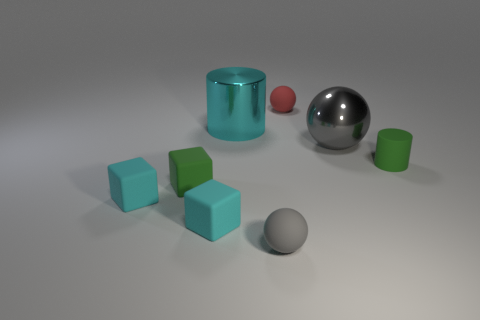Subtract all green spheres. How many cyan blocks are left? 2 Subtract all small cyan rubber blocks. How many blocks are left? 1 Add 1 small cyan cylinders. How many objects exist? 9 Subtract 1 blocks. How many blocks are left? 2 Subtract all cubes. How many objects are left? 5 Subtract all yellow balls. Subtract all red cylinders. How many balls are left? 3 Add 8 green cylinders. How many green cylinders are left? 9 Add 6 small cyan cubes. How many small cyan cubes exist? 8 Subtract 1 cyan cylinders. How many objects are left? 7 Subtract all small green things. Subtract all big cyan things. How many objects are left? 5 